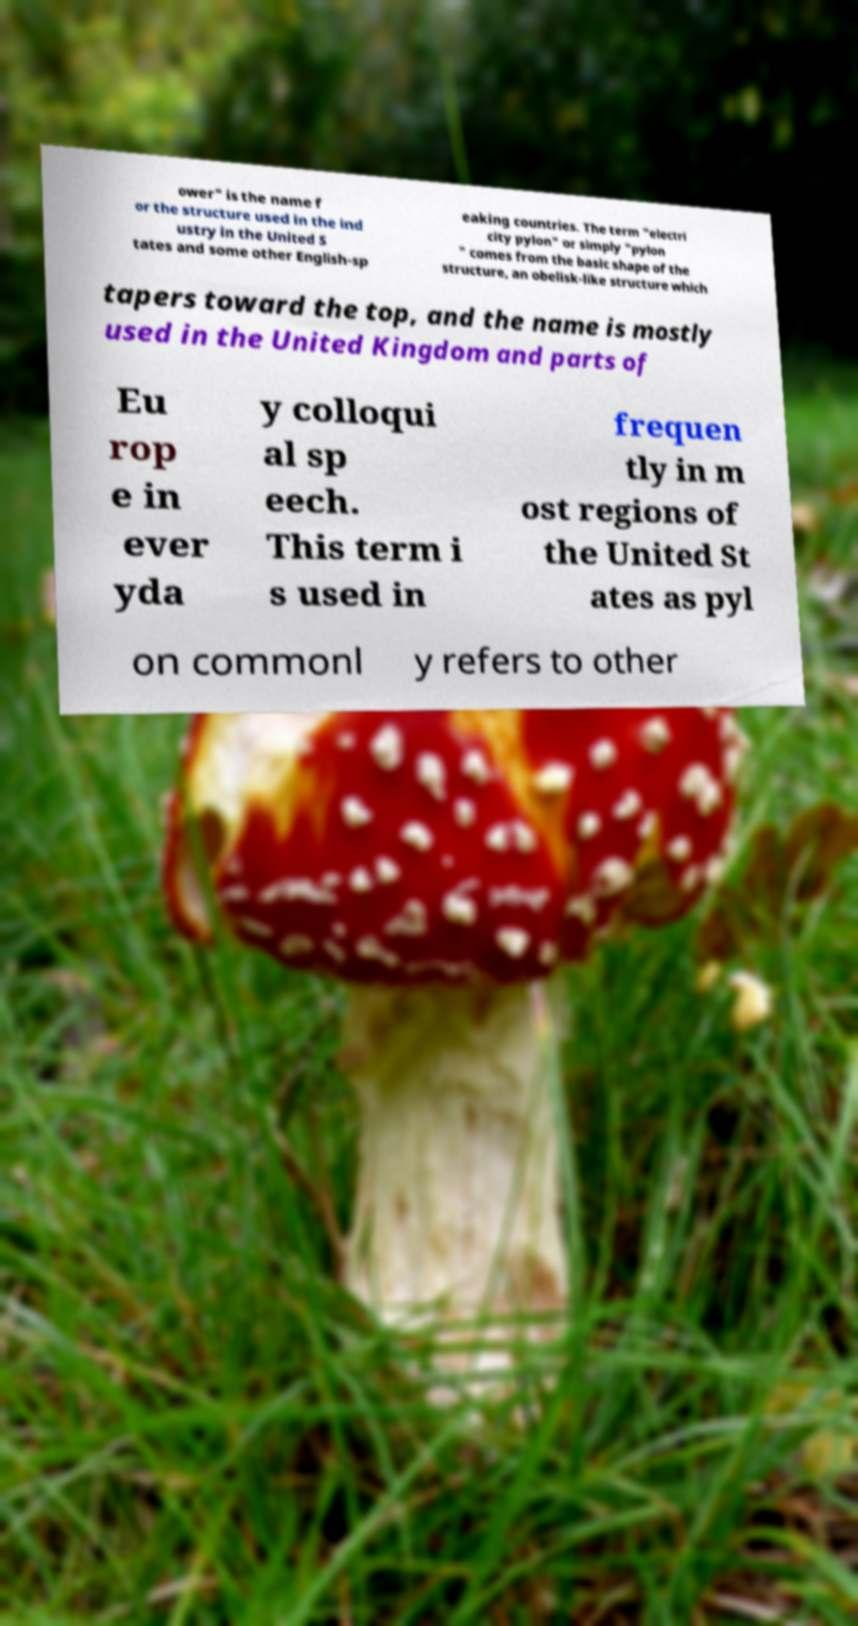Could you assist in decoding the text presented in this image and type it out clearly? ower" is the name f or the structure used in the ind ustry in the United S tates and some other English-sp eaking countries. The term "electri city pylon" or simply "pylon " comes from the basic shape of the structure, an obelisk-like structure which tapers toward the top, and the name is mostly used in the United Kingdom and parts of Eu rop e in ever yda y colloqui al sp eech. This term i s used in frequen tly in m ost regions of the United St ates as pyl on commonl y refers to other 